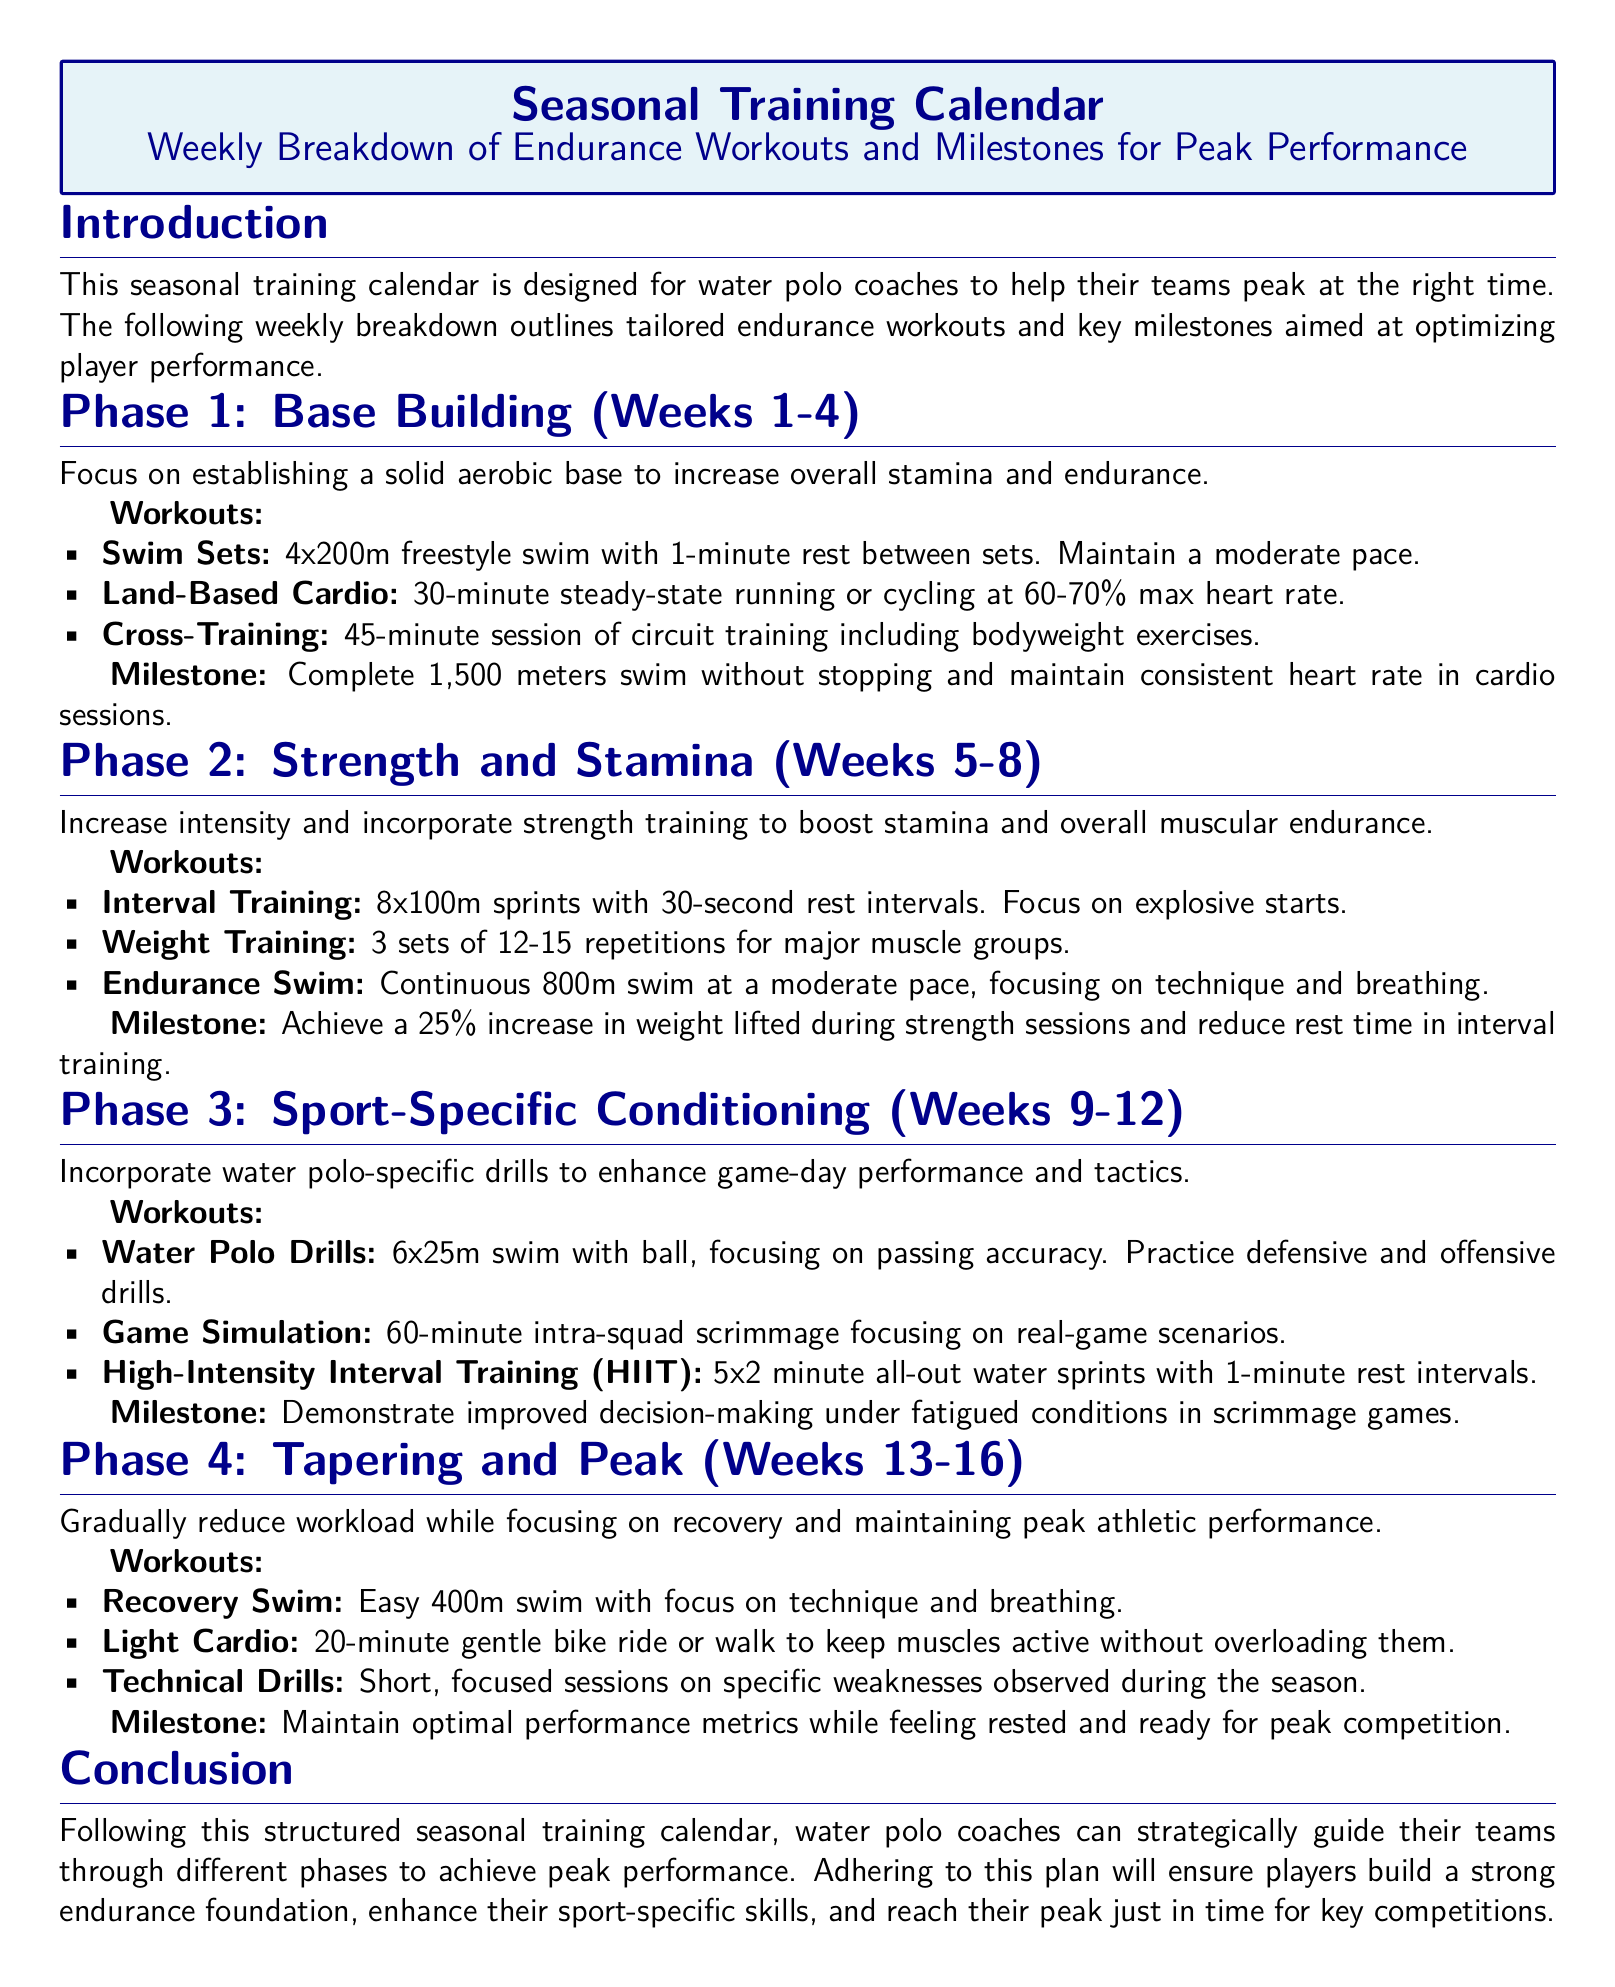What are the four phases of training? The document outlines four phases: Base Building, Strength and Stamina, Sport-Specific Conditioning, and Tapering and Peak.
Answer: Base Building, Strength and Stamina, Sport-Specific Conditioning, Tapering and Peak What is the main goal of Phase 1? Phase 1 primarily focuses on establishing a solid aerobic base to increase overall stamina and endurance.
Answer: Establishing a solid aerobic base How many weeks are dedicated to Tapering and Peak? Tapering and Peak lasts for four weeks, from week 13 to week 16.
Answer: Four weeks What is the milestone for Phase 3? The milestone for Phase 3 is improved decision-making under fatigued conditions during scrimmage games.
Answer: Improved decision-making under fatigued conditions What type of cardio is included in Phase 2? Phase 2 includes interval training as a cardio workout to increase intensity.
Answer: Interval training How long should the recovery swim be in the final phase? The recovery swim in Phase 4 is an easy 400m.
Answer: 400m How many repetitions do weight training sessions consist of in Phase 2? The weight training sessions consist of 12-15 repetitions for major muscle groups.
Answer: 12-15 repetitions What is the total distance for the swim sets in Phase 1? The total distance for the swim sets in Phase 1 is 800m in total (4x200m).
Answer: 800m What type of training is emphasized in the document? The document emphasizes endurance training for water polo coaches.
Answer: Endurance training 